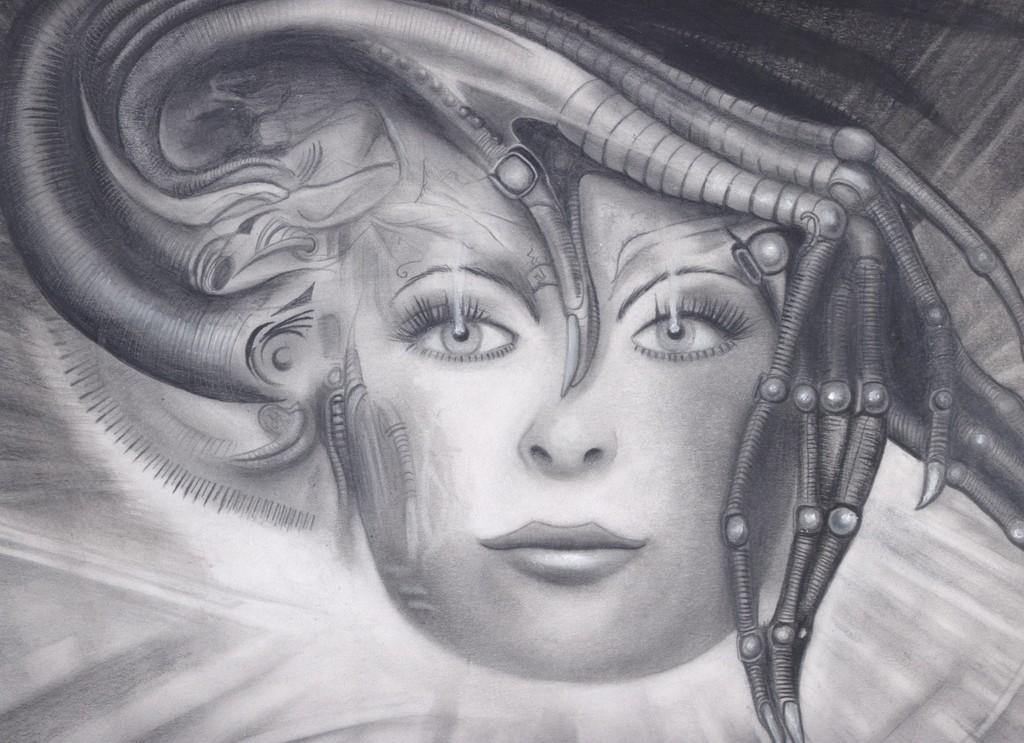What is the color scheme of the image? The image is black and white. What is depicted in the image? There is a drawing of a woman in the image. What is the woman wearing on her head? The woman is wearing a hat. What type of furniture can be seen in the image? There is no furniture present in the image; it features a drawing of a woman wearing a hat. How does the taste of the drawing change throughout the image? The image is black and white and does not depict taste or any edible subject matter. 